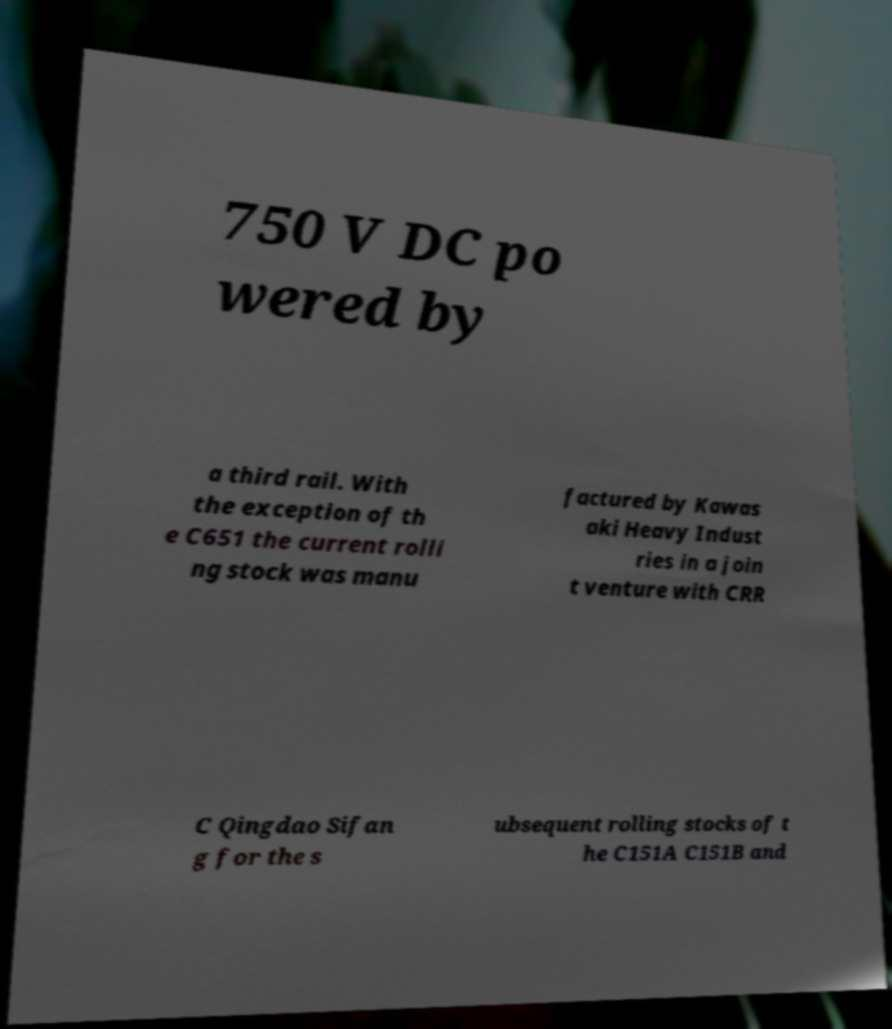Can you accurately transcribe the text from the provided image for me? 750 V DC po wered by a third rail. With the exception of th e C651 the current rolli ng stock was manu factured by Kawas aki Heavy Indust ries in a join t venture with CRR C Qingdao Sifan g for the s ubsequent rolling stocks of t he C151A C151B and 